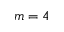<formula> <loc_0><loc_0><loc_500><loc_500>m = 4</formula> 